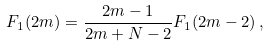Convert formula to latex. <formula><loc_0><loc_0><loc_500><loc_500>F _ { 1 } ( 2 m ) = \frac { 2 m - 1 } { 2 m + N - 2 } F _ { 1 } ( 2 m - 2 ) \, ,</formula> 